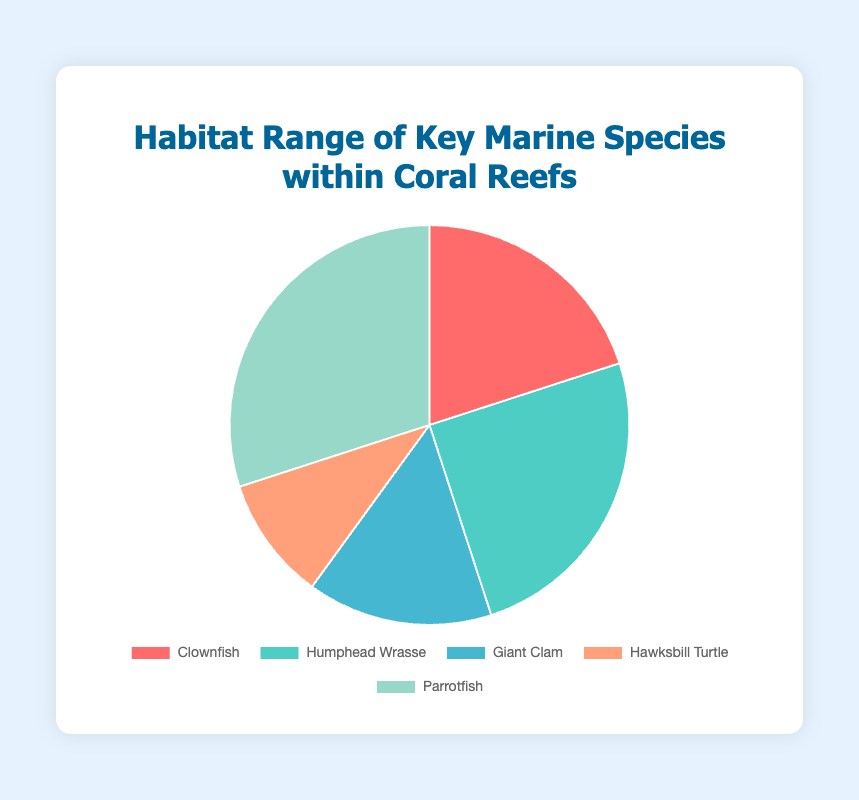Which species has the largest habitat range within the coral reefs? By looking at the pie chart, the slice corresponding to Parrotfish is the largest, indicating that Parrotfish has the largest habitat range.
Answer: Parrotfish Which species has the smallest habitat range within the coral reefs? By examining the pie chart, the Hawksbill Turtle's slice is the smallest, indicating that it has the smallest habitat range.
Answer: Hawksbill Turtle Is the habitat range of Clownfish greater than the habitat range of Giant Clam? By comparing the sizes of the pie slices, the Clownfish slice is larger than the Giant Clam slice, indicating that the habitat range of Clownfish is greater.
Answer: Yes What is the combined habitat range percentage of the Humphead Wrasse and Parrotfish? The Humphead Wrasse has a 25% range and the Parrotfish has a 30% range. Adding these percentages results in 25% + 30% = 55%.
Answer: 55% What is the difference in habitat range percentage between the largest and smallest species ranges? The largest habitat range is Parrotfish at 30% and the smallest is Hawksbill Turtle at 10%. The difference is 30% - 10% = 20%.
Answer: 20% What percentage of the habitat range is not covered by the Clownfish and Parrotfish combined? The Clownfish has a 20% range and the Parrotfish has a 30% range. Combined, that's 20% + 30% = 50%. Therefore, 100% - 50% = 50% of the habitat range is not covered by these two species.
Answer: 50% Which species' habitat range is represented by the blue slice in the pie chart? By looking at the pie chart, the blue slice corresponds to the Giant Clam.
Answer: Giant Clam How many species have a habitat range percentage greater than 20%? By examining the pie chart: Humphead Wrasse (25%) and Parrotfish (30%) have ranges greater than 20%.
Answer: 2 Is the habitat range of the Humphead Wrasse equal to the combined habitat range of the Clownfish and Hawksbill Turtle? The Humphead Wrasse has a 25% range. Clownfish have 20% and Hawksbill Turtle has 10%. Combined, 20% + 10% = 30%, which is not equal to 25%.
Answer: No 